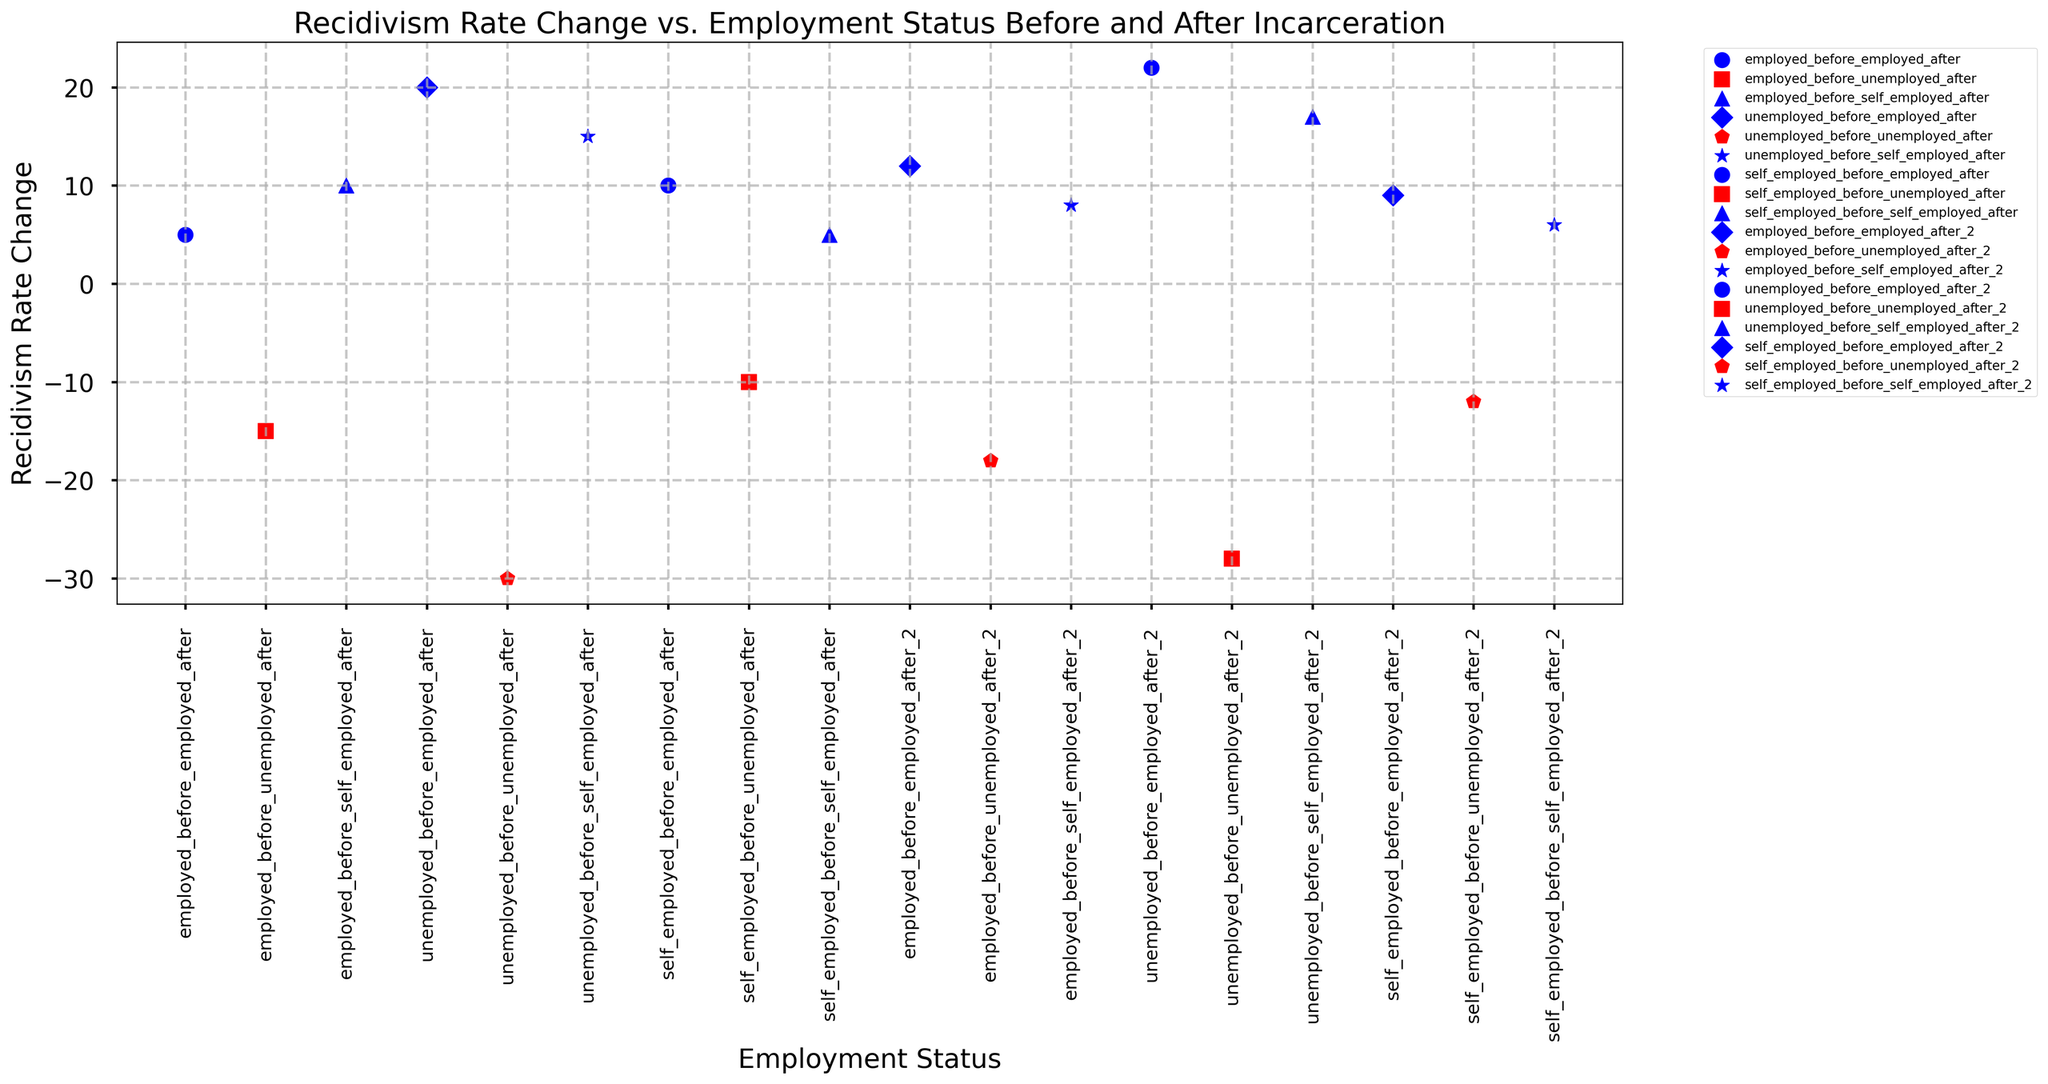What is the average recidivism rate change for individuals who were unemployed before incarceration but employed after? First, identify the recidivism rate changes for "unemployed_before_employed_after" which are 20 and 22. Sum these values which result in 42. Since there are 2 data points, divide 42 by 2 to get the average.
Answer: 21 Which employment status category has the highest recidivism rate change? Identify the recidivism rate changes for each category. The highest recidivism rate change is 22, which corresponds to the "unemployed_before_employed_after_2" category.
Answer: unemployed_before_employed_after_2 What is the difference in recidivism rate change between individuals who were employed before and unemployed after, and those who were unemployed before and unemployed after? The recidivism rate changes for "employed_before_unemployed_after" are -15 and -18, while for "unemployed_before_unemployed_after" they are -30 and -28. The average of these values are -16.5 and -29, respectively. The difference is -16.5 - (-29) = 12.5.
Answer: 12.5 Which categories have a negative average recidivism rate change? Calculate the average recidivism rate change for each category. Categories "employed_before_unemployed_after" (-16.5) and "self_employed_before_unemployed_after" (-11) have negative averages.
Answer: employed_before_unemployed_after, self_employed_before_unemployed_after What is the overall range of recidivism rate change across all categories? The minimum recidivism rate change is -30 (unemployed_before_unemployed_after), and the maximum is 22 (unemployed_before_employed_after_2). The range is 22 - (-30) = 52.
Answer: 52 